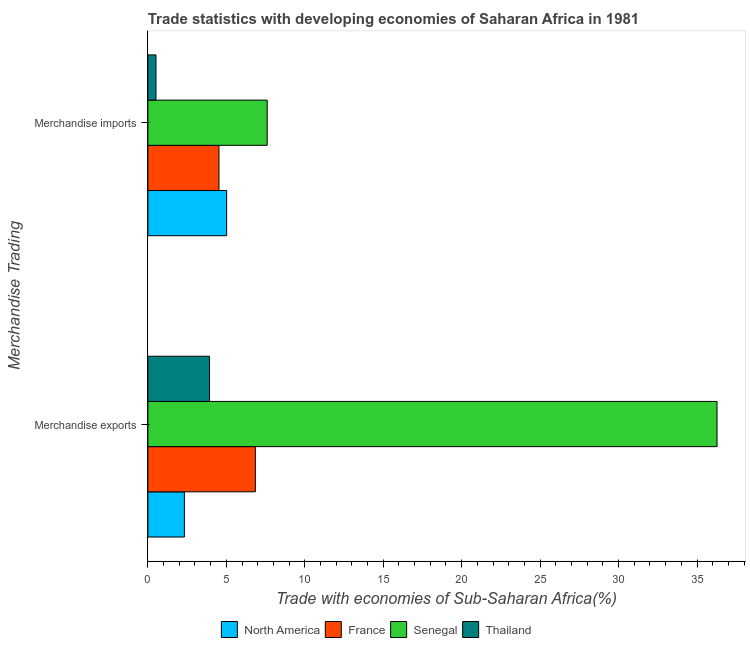How many different coloured bars are there?
Offer a terse response. 4. How many groups of bars are there?
Offer a very short reply. 2. Are the number of bars per tick equal to the number of legend labels?
Offer a very short reply. Yes. What is the label of the 2nd group of bars from the top?
Your answer should be compact. Merchandise exports. What is the merchandise imports in North America?
Offer a terse response. 5.02. Across all countries, what is the maximum merchandise exports?
Give a very brief answer. 36.27. Across all countries, what is the minimum merchandise exports?
Your answer should be very brief. 2.33. In which country was the merchandise imports maximum?
Ensure brevity in your answer.  Senegal. What is the total merchandise exports in the graph?
Ensure brevity in your answer.  49.38. What is the difference between the merchandise exports in France and that in Thailand?
Ensure brevity in your answer.  2.92. What is the difference between the merchandise exports in Thailand and the merchandise imports in North America?
Give a very brief answer. -1.09. What is the average merchandise imports per country?
Your response must be concise. 4.42. What is the difference between the merchandise imports and merchandise exports in Thailand?
Make the answer very short. -3.42. In how many countries, is the merchandise imports greater than 34 %?
Provide a short and direct response. 0. What is the ratio of the merchandise imports in North America to that in France?
Your answer should be very brief. 1.11. Is the merchandise exports in Thailand less than that in France?
Offer a very short reply. Yes. In how many countries, is the merchandise imports greater than the average merchandise imports taken over all countries?
Make the answer very short. 3. What does the 4th bar from the top in Merchandise exports represents?
Provide a short and direct response. North America. What does the 4th bar from the bottom in Merchandise exports represents?
Make the answer very short. Thailand. Are all the bars in the graph horizontal?
Keep it short and to the point. Yes. How many countries are there in the graph?
Your answer should be compact. 4. What is the difference between two consecutive major ticks on the X-axis?
Offer a very short reply. 5. Does the graph contain any zero values?
Offer a terse response. No. Does the graph contain grids?
Keep it short and to the point. No. How are the legend labels stacked?
Provide a short and direct response. Horizontal. What is the title of the graph?
Provide a short and direct response. Trade statistics with developing economies of Saharan Africa in 1981. Does "Rwanda" appear as one of the legend labels in the graph?
Offer a terse response. No. What is the label or title of the X-axis?
Offer a very short reply. Trade with economies of Sub-Saharan Africa(%). What is the label or title of the Y-axis?
Provide a succinct answer. Merchandise Trading. What is the Trade with economies of Sub-Saharan Africa(%) of North America in Merchandise exports?
Your response must be concise. 2.33. What is the Trade with economies of Sub-Saharan Africa(%) of France in Merchandise exports?
Provide a short and direct response. 6.85. What is the Trade with economies of Sub-Saharan Africa(%) of Senegal in Merchandise exports?
Ensure brevity in your answer.  36.27. What is the Trade with economies of Sub-Saharan Africa(%) in Thailand in Merchandise exports?
Your answer should be compact. 3.93. What is the Trade with economies of Sub-Saharan Africa(%) in North America in Merchandise imports?
Offer a terse response. 5.02. What is the Trade with economies of Sub-Saharan Africa(%) in France in Merchandise imports?
Your answer should be compact. 4.53. What is the Trade with economies of Sub-Saharan Africa(%) of Senegal in Merchandise imports?
Your answer should be compact. 7.61. What is the Trade with economies of Sub-Saharan Africa(%) in Thailand in Merchandise imports?
Offer a very short reply. 0.52. Across all Merchandise Trading, what is the maximum Trade with economies of Sub-Saharan Africa(%) of North America?
Provide a succinct answer. 5.02. Across all Merchandise Trading, what is the maximum Trade with economies of Sub-Saharan Africa(%) of France?
Offer a terse response. 6.85. Across all Merchandise Trading, what is the maximum Trade with economies of Sub-Saharan Africa(%) of Senegal?
Your answer should be very brief. 36.27. Across all Merchandise Trading, what is the maximum Trade with economies of Sub-Saharan Africa(%) of Thailand?
Keep it short and to the point. 3.93. Across all Merchandise Trading, what is the minimum Trade with economies of Sub-Saharan Africa(%) in North America?
Keep it short and to the point. 2.33. Across all Merchandise Trading, what is the minimum Trade with economies of Sub-Saharan Africa(%) of France?
Offer a very short reply. 4.53. Across all Merchandise Trading, what is the minimum Trade with economies of Sub-Saharan Africa(%) of Senegal?
Your response must be concise. 7.61. Across all Merchandise Trading, what is the minimum Trade with economies of Sub-Saharan Africa(%) of Thailand?
Ensure brevity in your answer.  0.52. What is the total Trade with economies of Sub-Saharan Africa(%) in North America in the graph?
Ensure brevity in your answer.  7.35. What is the total Trade with economies of Sub-Saharan Africa(%) in France in the graph?
Keep it short and to the point. 11.38. What is the total Trade with economies of Sub-Saharan Africa(%) of Senegal in the graph?
Keep it short and to the point. 43.88. What is the total Trade with economies of Sub-Saharan Africa(%) of Thailand in the graph?
Offer a very short reply. 4.45. What is the difference between the Trade with economies of Sub-Saharan Africa(%) of North America in Merchandise exports and that in Merchandise imports?
Offer a very short reply. -2.7. What is the difference between the Trade with economies of Sub-Saharan Africa(%) of France in Merchandise exports and that in Merchandise imports?
Give a very brief answer. 2.32. What is the difference between the Trade with economies of Sub-Saharan Africa(%) in Senegal in Merchandise exports and that in Merchandise imports?
Provide a succinct answer. 28.67. What is the difference between the Trade with economies of Sub-Saharan Africa(%) of Thailand in Merchandise exports and that in Merchandise imports?
Your answer should be compact. 3.42. What is the difference between the Trade with economies of Sub-Saharan Africa(%) of North America in Merchandise exports and the Trade with economies of Sub-Saharan Africa(%) of France in Merchandise imports?
Make the answer very short. -2.21. What is the difference between the Trade with economies of Sub-Saharan Africa(%) in North America in Merchandise exports and the Trade with economies of Sub-Saharan Africa(%) in Senegal in Merchandise imports?
Keep it short and to the point. -5.28. What is the difference between the Trade with economies of Sub-Saharan Africa(%) in North America in Merchandise exports and the Trade with economies of Sub-Saharan Africa(%) in Thailand in Merchandise imports?
Your answer should be compact. 1.81. What is the difference between the Trade with economies of Sub-Saharan Africa(%) of France in Merchandise exports and the Trade with economies of Sub-Saharan Africa(%) of Senegal in Merchandise imports?
Provide a succinct answer. -0.76. What is the difference between the Trade with economies of Sub-Saharan Africa(%) of France in Merchandise exports and the Trade with economies of Sub-Saharan Africa(%) of Thailand in Merchandise imports?
Your answer should be compact. 6.33. What is the difference between the Trade with economies of Sub-Saharan Africa(%) of Senegal in Merchandise exports and the Trade with economies of Sub-Saharan Africa(%) of Thailand in Merchandise imports?
Your answer should be very brief. 35.76. What is the average Trade with economies of Sub-Saharan Africa(%) of North America per Merchandise Trading?
Give a very brief answer. 3.67. What is the average Trade with economies of Sub-Saharan Africa(%) in France per Merchandise Trading?
Keep it short and to the point. 5.69. What is the average Trade with economies of Sub-Saharan Africa(%) in Senegal per Merchandise Trading?
Keep it short and to the point. 21.94. What is the average Trade with economies of Sub-Saharan Africa(%) in Thailand per Merchandise Trading?
Make the answer very short. 2.22. What is the difference between the Trade with economies of Sub-Saharan Africa(%) of North America and Trade with economies of Sub-Saharan Africa(%) of France in Merchandise exports?
Provide a succinct answer. -4.52. What is the difference between the Trade with economies of Sub-Saharan Africa(%) of North America and Trade with economies of Sub-Saharan Africa(%) of Senegal in Merchandise exports?
Offer a very short reply. -33.95. What is the difference between the Trade with economies of Sub-Saharan Africa(%) in North America and Trade with economies of Sub-Saharan Africa(%) in Thailand in Merchandise exports?
Your answer should be very brief. -1.6. What is the difference between the Trade with economies of Sub-Saharan Africa(%) in France and Trade with economies of Sub-Saharan Africa(%) in Senegal in Merchandise exports?
Provide a succinct answer. -29.43. What is the difference between the Trade with economies of Sub-Saharan Africa(%) in France and Trade with economies of Sub-Saharan Africa(%) in Thailand in Merchandise exports?
Your response must be concise. 2.92. What is the difference between the Trade with economies of Sub-Saharan Africa(%) in Senegal and Trade with economies of Sub-Saharan Africa(%) in Thailand in Merchandise exports?
Keep it short and to the point. 32.34. What is the difference between the Trade with economies of Sub-Saharan Africa(%) of North America and Trade with economies of Sub-Saharan Africa(%) of France in Merchandise imports?
Provide a succinct answer. 0.49. What is the difference between the Trade with economies of Sub-Saharan Africa(%) in North America and Trade with economies of Sub-Saharan Africa(%) in Senegal in Merchandise imports?
Provide a succinct answer. -2.58. What is the difference between the Trade with economies of Sub-Saharan Africa(%) in North America and Trade with economies of Sub-Saharan Africa(%) in Thailand in Merchandise imports?
Your response must be concise. 4.51. What is the difference between the Trade with economies of Sub-Saharan Africa(%) of France and Trade with economies of Sub-Saharan Africa(%) of Senegal in Merchandise imports?
Give a very brief answer. -3.07. What is the difference between the Trade with economies of Sub-Saharan Africa(%) of France and Trade with economies of Sub-Saharan Africa(%) of Thailand in Merchandise imports?
Make the answer very short. 4.02. What is the difference between the Trade with economies of Sub-Saharan Africa(%) in Senegal and Trade with economies of Sub-Saharan Africa(%) in Thailand in Merchandise imports?
Provide a short and direct response. 7.09. What is the ratio of the Trade with economies of Sub-Saharan Africa(%) in North America in Merchandise exports to that in Merchandise imports?
Ensure brevity in your answer.  0.46. What is the ratio of the Trade with economies of Sub-Saharan Africa(%) of France in Merchandise exports to that in Merchandise imports?
Your response must be concise. 1.51. What is the ratio of the Trade with economies of Sub-Saharan Africa(%) of Senegal in Merchandise exports to that in Merchandise imports?
Your response must be concise. 4.77. What is the ratio of the Trade with economies of Sub-Saharan Africa(%) of Thailand in Merchandise exports to that in Merchandise imports?
Provide a short and direct response. 7.63. What is the difference between the highest and the second highest Trade with economies of Sub-Saharan Africa(%) of North America?
Offer a very short reply. 2.7. What is the difference between the highest and the second highest Trade with economies of Sub-Saharan Africa(%) in France?
Provide a short and direct response. 2.32. What is the difference between the highest and the second highest Trade with economies of Sub-Saharan Africa(%) of Senegal?
Keep it short and to the point. 28.67. What is the difference between the highest and the second highest Trade with economies of Sub-Saharan Africa(%) of Thailand?
Give a very brief answer. 3.42. What is the difference between the highest and the lowest Trade with economies of Sub-Saharan Africa(%) in North America?
Ensure brevity in your answer.  2.7. What is the difference between the highest and the lowest Trade with economies of Sub-Saharan Africa(%) in France?
Your answer should be compact. 2.32. What is the difference between the highest and the lowest Trade with economies of Sub-Saharan Africa(%) in Senegal?
Make the answer very short. 28.67. What is the difference between the highest and the lowest Trade with economies of Sub-Saharan Africa(%) of Thailand?
Your answer should be very brief. 3.42. 